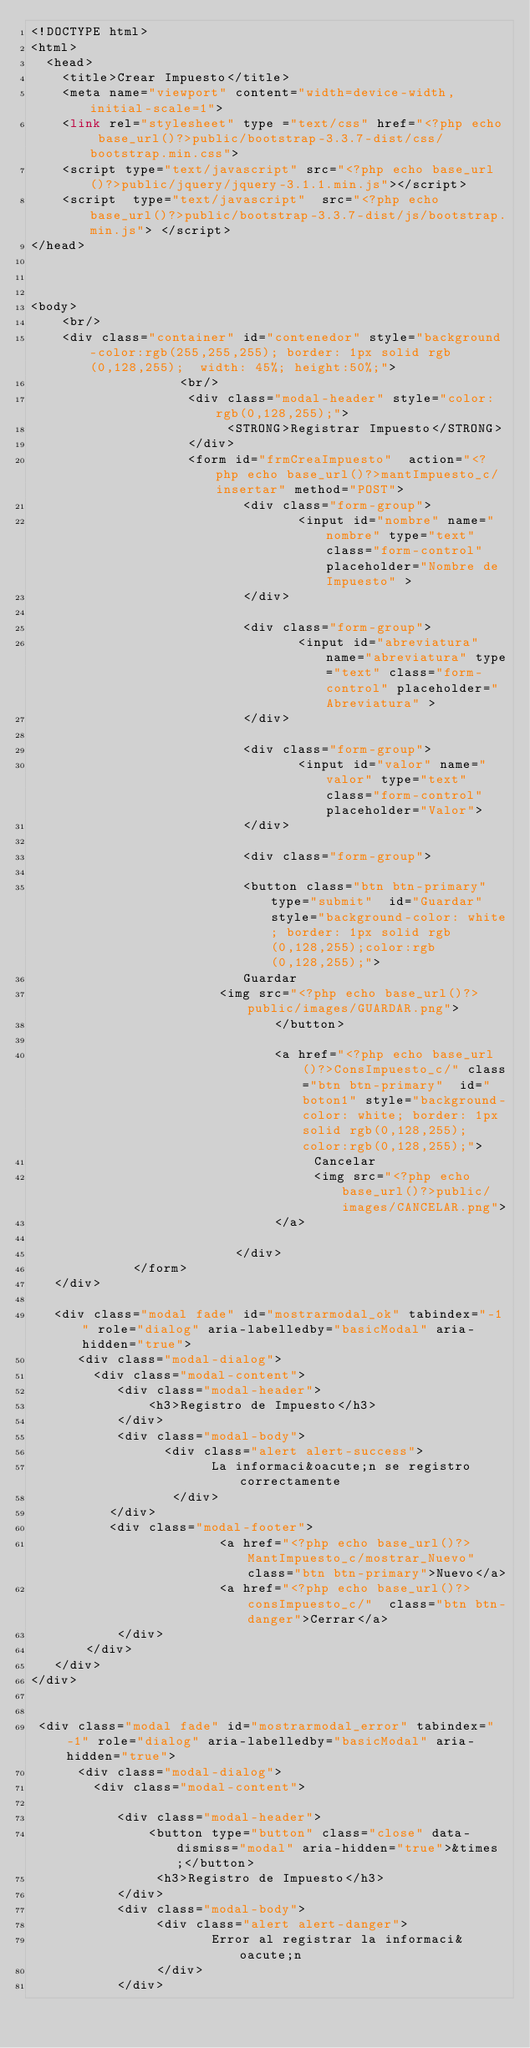Convert code to text. <code><loc_0><loc_0><loc_500><loc_500><_PHP_><!DOCTYPE html> 
<html> 
  <head> 
    <title>Crear Impuesto</title> 
    <meta name="viewport" content="width=device-width, initial-scale=1">
    <link rel="stylesheet" type ="text/css" href="<?php echo base_url()?>public/bootstrap-3.3.7-dist/css/bootstrap.min.css"> 
    <script type="text/javascript" src="<?php echo base_url()?>public/jquery/jquery-3.1.1.min.js"></script>
    <script  type="text/javascript"  src="<?php echo base_url()?>public/bootstrap-3.3.7-dist/js/bootstrap.min.js"> </script>
</head>

 

<body>
    <br/>
	<div class="container" id="contenedor" style="background-color:rgb(255,255,255); border: 1px solid rgb(0,128,255);  width: 45%; height:50%;">
		           <br/>
		            <div class="modal-header" style="color:rgb(0,128,255);"> 
		                 <STRONG>Registrar Impuesto</STRONG>
		            </div>
				    <form id="frmCreaImpuesto"  action="<?php echo base_url()?>mantImpuesto_c/insertar" method="POST">
					       <div class="form-group">
						          <input id="nombre" name="nombre" type="text" class="form-control" placeholder="Nombre de Impuesto" >
						   </div>
						   
						   <div class="form-group">
						          <input id="abreviatura" name="abreviatura" type="text" class="form-control" placeholder="Abreviatura" >
						   </div>
						   
						   <div class="form-group">
						          <input id="valor" name="valor" type="text" class="form-control" placeholder="Valor">
						   </div>
						   
						   <div class="form-group">
							 
                           <button class="btn btn-primary" type="submit"  id="Guardar" style="background-color: white; border: 1px solid rgb(0,128,255);color:rgb(0,128,255);">
						   Guardar
						<img src="<?php echo base_url()?>public/images/GUARDAR.png">
							   </button>
							     
							   <a href="<?php echo base_url()?>ConsImpuesto_c/" class="btn btn-primary"  id="boton1" style="background-color: white; border: 1px solid rgb(0,128,255); color:rgb(0,128,255);">
							        Cancelar
							        <img src="<?php echo base_url()?>public/images/CANCELAR.png">
							   </a>
						 
						  </div>   
			 </form>
   </div>

   <div class="modal fade" id="mostrarmodal_ok" tabindex="-1" role="dialog" aria-labelledby="basicModal" aria-hidden="true">
      <div class="modal-dialog">
        <div class="modal-content">
           <div class="modal-header">
               <h3>Registro de Impuesto</h3>
           </div>
           <div class="modal-body">
            	 <div class="alert alert-success">
     		           La informaci&oacute;n se registro correctamente 
     		      </div>
          </div>
          <div class="modal-footer">
          				<a href="<?php echo base_url()?>MantImpuesto_c/mostrar_Nuevo" class="btn btn-primary">Nuevo</a>
          				<a href="<?php echo base_url()?>consImpuesto_c/"  class="btn btn-danger">Cerrar</a>
           </div>
       </div>
   </div>
</div>


 <div class="modal fade" id="mostrarmodal_error" tabindex="-1" role="dialog" aria-labelledby="basicModal" aria-hidden="true">
      <div class="modal-dialog">
        <div class="modal-content">
     
           <div class="modal-header">
               <button type="button" class="close" data-dismiss="modal" aria-hidden="true">&times;</button>
                <h3>Registro de Impuesto</h3>
           </div>
           <div class="modal-body">
          		<div class="alert alert-danger">
             		   Error al registrar la informaci&oacute;n
          		</div>
           </div></code> 